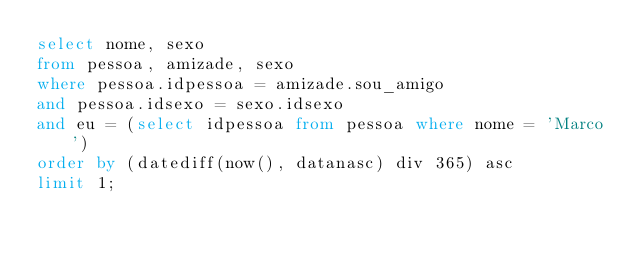Convert code to text. <code><loc_0><loc_0><loc_500><loc_500><_SQL_>select nome, sexo
from pessoa, amizade, sexo
where pessoa.idpessoa = amizade.sou_amigo
and pessoa.idsexo = sexo.idsexo
and eu = (select idpessoa from pessoa where nome = 'Marco')
order by (datediff(now(), datanasc) div 365) asc
limit 1;</code> 